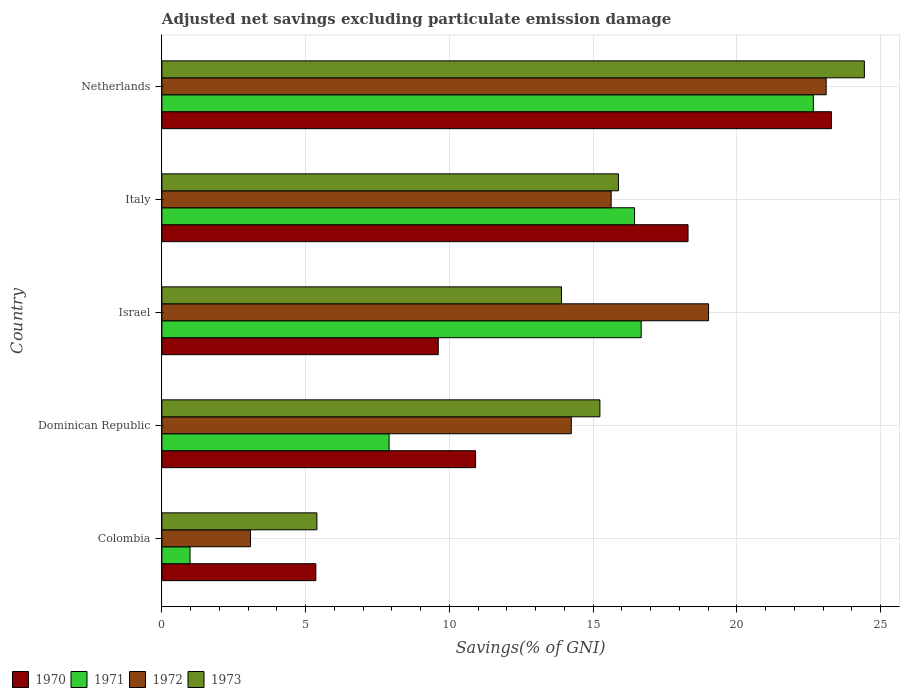How many groups of bars are there?
Your response must be concise. 5. Are the number of bars on each tick of the Y-axis equal?
Give a very brief answer. Yes. How many bars are there on the 1st tick from the top?
Your answer should be compact. 4. How many bars are there on the 5th tick from the bottom?
Make the answer very short. 4. What is the label of the 5th group of bars from the top?
Offer a terse response. Colombia. What is the adjusted net savings in 1970 in Colombia?
Offer a terse response. 5.36. Across all countries, what is the maximum adjusted net savings in 1973?
Offer a terse response. 24.44. Across all countries, what is the minimum adjusted net savings in 1972?
Give a very brief answer. 3.08. What is the total adjusted net savings in 1973 in the graph?
Your answer should be compact. 74.85. What is the difference between the adjusted net savings in 1972 in Dominican Republic and that in Israel?
Ensure brevity in your answer.  -4.78. What is the difference between the adjusted net savings in 1971 in Dominican Republic and the adjusted net savings in 1973 in Netherlands?
Your response must be concise. -16.53. What is the average adjusted net savings in 1973 per country?
Your response must be concise. 14.97. What is the difference between the adjusted net savings in 1971 and adjusted net savings in 1973 in Dominican Republic?
Keep it short and to the point. -7.33. In how many countries, is the adjusted net savings in 1973 greater than 5 %?
Offer a very short reply. 5. What is the ratio of the adjusted net savings in 1973 in Dominican Republic to that in Netherlands?
Your answer should be very brief. 0.62. Is the difference between the adjusted net savings in 1971 in Colombia and Dominican Republic greater than the difference between the adjusted net savings in 1973 in Colombia and Dominican Republic?
Offer a terse response. Yes. What is the difference between the highest and the second highest adjusted net savings in 1973?
Your response must be concise. 8.56. What is the difference between the highest and the lowest adjusted net savings in 1971?
Ensure brevity in your answer.  21.68. Is the sum of the adjusted net savings in 1973 in Colombia and Italy greater than the maximum adjusted net savings in 1972 across all countries?
Your answer should be very brief. No. Is it the case that in every country, the sum of the adjusted net savings in 1972 and adjusted net savings in 1973 is greater than the sum of adjusted net savings in 1971 and adjusted net savings in 1970?
Ensure brevity in your answer.  No. What does the 4th bar from the bottom in Colombia represents?
Your answer should be very brief. 1973. Is it the case that in every country, the sum of the adjusted net savings in 1973 and adjusted net savings in 1971 is greater than the adjusted net savings in 1970?
Your answer should be very brief. Yes. Are all the bars in the graph horizontal?
Ensure brevity in your answer.  Yes. Are the values on the major ticks of X-axis written in scientific E-notation?
Provide a succinct answer. No. Does the graph contain any zero values?
Keep it short and to the point. No. Does the graph contain grids?
Make the answer very short. Yes. Where does the legend appear in the graph?
Provide a short and direct response. Bottom left. What is the title of the graph?
Your response must be concise. Adjusted net savings excluding particulate emission damage. What is the label or title of the X-axis?
Keep it short and to the point. Savings(% of GNI). What is the label or title of the Y-axis?
Provide a succinct answer. Country. What is the Savings(% of GNI) in 1970 in Colombia?
Provide a short and direct response. 5.36. What is the Savings(% of GNI) in 1971 in Colombia?
Offer a terse response. 0.98. What is the Savings(% of GNI) of 1972 in Colombia?
Ensure brevity in your answer.  3.08. What is the Savings(% of GNI) of 1973 in Colombia?
Your answer should be compact. 5.39. What is the Savings(% of GNI) of 1970 in Dominican Republic?
Give a very brief answer. 10.91. What is the Savings(% of GNI) in 1971 in Dominican Republic?
Your response must be concise. 7.9. What is the Savings(% of GNI) in 1972 in Dominican Republic?
Give a very brief answer. 14.24. What is the Savings(% of GNI) of 1973 in Dominican Republic?
Provide a short and direct response. 15.24. What is the Savings(% of GNI) in 1970 in Israel?
Provide a short and direct response. 9.61. What is the Savings(% of GNI) of 1971 in Israel?
Ensure brevity in your answer.  16.67. What is the Savings(% of GNI) of 1972 in Israel?
Provide a succinct answer. 19.02. What is the Savings(% of GNI) of 1973 in Israel?
Your answer should be very brief. 13.9. What is the Savings(% of GNI) in 1970 in Italy?
Give a very brief answer. 18.3. What is the Savings(% of GNI) in 1971 in Italy?
Ensure brevity in your answer.  16.44. What is the Savings(% of GNI) in 1972 in Italy?
Make the answer very short. 15.63. What is the Savings(% of GNI) in 1973 in Italy?
Give a very brief answer. 15.88. What is the Savings(% of GNI) in 1970 in Netherlands?
Offer a terse response. 23.3. What is the Savings(% of GNI) in 1971 in Netherlands?
Give a very brief answer. 22.66. What is the Savings(% of GNI) of 1972 in Netherlands?
Give a very brief answer. 23.11. What is the Savings(% of GNI) of 1973 in Netherlands?
Provide a short and direct response. 24.44. Across all countries, what is the maximum Savings(% of GNI) of 1970?
Provide a succinct answer. 23.3. Across all countries, what is the maximum Savings(% of GNI) of 1971?
Your response must be concise. 22.66. Across all countries, what is the maximum Savings(% of GNI) of 1972?
Make the answer very short. 23.11. Across all countries, what is the maximum Savings(% of GNI) in 1973?
Your answer should be compact. 24.44. Across all countries, what is the minimum Savings(% of GNI) of 1970?
Your response must be concise. 5.36. Across all countries, what is the minimum Savings(% of GNI) of 1971?
Ensure brevity in your answer.  0.98. Across all countries, what is the minimum Savings(% of GNI) in 1972?
Offer a very short reply. 3.08. Across all countries, what is the minimum Savings(% of GNI) of 1973?
Your answer should be very brief. 5.39. What is the total Savings(% of GNI) in 1970 in the graph?
Offer a terse response. 67.48. What is the total Savings(% of GNI) in 1971 in the graph?
Ensure brevity in your answer.  64.66. What is the total Savings(% of GNI) of 1972 in the graph?
Offer a very short reply. 75.08. What is the total Savings(% of GNI) in 1973 in the graph?
Provide a succinct answer. 74.85. What is the difference between the Savings(% of GNI) in 1970 in Colombia and that in Dominican Republic?
Keep it short and to the point. -5.56. What is the difference between the Savings(% of GNI) in 1971 in Colombia and that in Dominican Republic?
Offer a very short reply. -6.92. What is the difference between the Savings(% of GNI) in 1972 in Colombia and that in Dominican Republic?
Your response must be concise. -11.16. What is the difference between the Savings(% of GNI) of 1973 in Colombia and that in Dominican Republic?
Provide a succinct answer. -9.85. What is the difference between the Savings(% of GNI) of 1970 in Colombia and that in Israel?
Make the answer very short. -4.26. What is the difference between the Savings(% of GNI) of 1971 in Colombia and that in Israel?
Offer a very short reply. -15.7. What is the difference between the Savings(% of GNI) in 1972 in Colombia and that in Israel?
Provide a succinct answer. -15.94. What is the difference between the Savings(% of GNI) of 1973 in Colombia and that in Israel?
Your response must be concise. -8.51. What is the difference between the Savings(% of GNI) of 1970 in Colombia and that in Italy?
Provide a short and direct response. -12.95. What is the difference between the Savings(% of GNI) in 1971 in Colombia and that in Italy?
Your response must be concise. -15.46. What is the difference between the Savings(% of GNI) in 1972 in Colombia and that in Italy?
Offer a terse response. -12.55. What is the difference between the Savings(% of GNI) of 1973 in Colombia and that in Italy?
Provide a succinct answer. -10.49. What is the difference between the Savings(% of GNI) in 1970 in Colombia and that in Netherlands?
Provide a short and direct response. -17.94. What is the difference between the Savings(% of GNI) of 1971 in Colombia and that in Netherlands?
Offer a very short reply. -21.68. What is the difference between the Savings(% of GNI) of 1972 in Colombia and that in Netherlands?
Provide a succinct answer. -20.03. What is the difference between the Savings(% of GNI) in 1973 in Colombia and that in Netherlands?
Provide a short and direct response. -19.05. What is the difference between the Savings(% of GNI) in 1970 in Dominican Republic and that in Israel?
Provide a short and direct response. 1.3. What is the difference between the Savings(% of GNI) in 1971 in Dominican Republic and that in Israel?
Your response must be concise. -8.77. What is the difference between the Savings(% of GNI) of 1972 in Dominican Republic and that in Israel?
Make the answer very short. -4.78. What is the difference between the Savings(% of GNI) in 1973 in Dominican Republic and that in Israel?
Your response must be concise. 1.34. What is the difference between the Savings(% of GNI) in 1970 in Dominican Republic and that in Italy?
Keep it short and to the point. -7.39. What is the difference between the Savings(% of GNI) of 1971 in Dominican Republic and that in Italy?
Ensure brevity in your answer.  -8.54. What is the difference between the Savings(% of GNI) of 1972 in Dominican Republic and that in Italy?
Offer a very short reply. -1.39. What is the difference between the Savings(% of GNI) of 1973 in Dominican Republic and that in Italy?
Provide a succinct answer. -0.65. What is the difference between the Savings(% of GNI) of 1970 in Dominican Republic and that in Netherlands?
Your answer should be very brief. -12.38. What is the difference between the Savings(% of GNI) in 1971 in Dominican Republic and that in Netherlands?
Provide a short and direct response. -14.76. What is the difference between the Savings(% of GNI) of 1972 in Dominican Republic and that in Netherlands?
Ensure brevity in your answer.  -8.87. What is the difference between the Savings(% of GNI) of 1973 in Dominican Republic and that in Netherlands?
Offer a terse response. -9.2. What is the difference between the Savings(% of GNI) of 1970 in Israel and that in Italy?
Offer a very short reply. -8.69. What is the difference between the Savings(% of GNI) in 1971 in Israel and that in Italy?
Your answer should be compact. 0.23. What is the difference between the Savings(% of GNI) of 1972 in Israel and that in Italy?
Ensure brevity in your answer.  3.39. What is the difference between the Savings(% of GNI) of 1973 in Israel and that in Italy?
Give a very brief answer. -1.98. What is the difference between the Savings(% of GNI) in 1970 in Israel and that in Netherlands?
Your answer should be compact. -13.68. What is the difference between the Savings(% of GNI) in 1971 in Israel and that in Netherlands?
Your answer should be compact. -5.99. What is the difference between the Savings(% of GNI) of 1972 in Israel and that in Netherlands?
Keep it short and to the point. -4.09. What is the difference between the Savings(% of GNI) in 1973 in Israel and that in Netherlands?
Provide a succinct answer. -10.54. What is the difference between the Savings(% of GNI) of 1970 in Italy and that in Netherlands?
Your answer should be compact. -4.99. What is the difference between the Savings(% of GNI) of 1971 in Italy and that in Netherlands?
Provide a succinct answer. -6.22. What is the difference between the Savings(% of GNI) of 1972 in Italy and that in Netherlands?
Your answer should be compact. -7.48. What is the difference between the Savings(% of GNI) in 1973 in Italy and that in Netherlands?
Give a very brief answer. -8.56. What is the difference between the Savings(% of GNI) in 1970 in Colombia and the Savings(% of GNI) in 1971 in Dominican Republic?
Give a very brief answer. -2.55. What is the difference between the Savings(% of GNI) of 1970 in Colombia and the Savings(% of GNI) of 1972 in Dominican Republic?
Make the answer very short. -8.89. What is the difference between the Savings(% of GNI) of 1970 in Colombia and the Savings(% of GNI) of 1973 in Dominican Republic?
Offer a terse response. -9.88. What is the difference between the Savings(% of GNI) in 1971 in Colombia and the Savings(% of GNI) in 1972 in Dominican Republic?
Keep it short and to the point. -13.26. What is the difference between the Savings(% of GNI) of 1971 in Colombia and the Savings(% of GNI) of 1973 in Dominican Republic?
Offer a terse response. -14.26. What is the difference between the Savings(% of GNI) in 1972 in Colombia and the Savings(% of GNI) in 1973 in Dominican Republic?
Your answer should be very brief. -12.15. What is the difference between the Savings(% of GNI) in 1970 in Colombia and the Savings(% of GNI) in 1971 in Israel?
Provide a short and direct response. -11.32. What is the difference between the Savings(% of GNI) of 1970 in Colombia and the Savings(% of GNI) of 1972 in Israel?
Provide a short and direct response. -13.66. What is the difference between the Savings(% of GNI) in 1970 in Colombia and the Savings(% of GNI) in 1973 in Israel?
Your answer should be very brief. -8.55. What is the difference between the Savings(% of GNI) of 1971 in Colombia and the Savings(% of GNI) of 1972 in Israel?
Your answer should be very brief. -18.04. What is the difference between the Savings(% of GNI) in 1971 in Colombia and the Savings(% of GNI) in 1973 in Israel?
Provide a short and direct response. -12.92. What is the difference between the Savings(% of GNI) of 1972 in Colombia and the Savings(% of GNI) of 1973 in Israel?
Offer a very short reply. -10.82. What is the difference between the Savings(% of GNI) in 1970 in Colombia and the Savings(% of GNI) in 1971 in Italy?
Offer a terse response. -11.09. What is the difference between the Savings(% of GNI) in 1970 in Colombia and the Savings(% of GNI) in 1972 in Italy?
Offer a very short reply. -10.27. What is the difference between the Savings(% of GNI) of 1970 in Colombia and the Savings(% of GNI) of 1973 in Italy?
Make the answer very short. -10.53. What is the difference between the Savings(% of GNI) of 1971 in Colombia and the Savings(% of GNI) of 1972 in Italy?
Your answer should be very brief. -14.65. What is the difference between the Savings(% of GNI) of 1971 in Colombia and the Savings(% of GNI) of 1973 in Italy?
Offer a very short reply. -14.9. What is the difference between the Savings(% of GNI) in 1972 in Colombia and the Savings(% of GNI) in 1973 in Italy?
Your response must be concise. -12.8. What is the difference between the Savings(% of GNI) of 1970 in Colombia and the Savings(% of GNI) of 1971 in Netherlands?
Keep it short and to the point. -17.31. What is the difference between the Savings(% of GNI) of 1970 in Colombia and the Savings(% of GNI) of 1972 in Netherlands?
Ensure brevity in your answer.  -17.75. What is the difference between the Savings(% of GNI) of 1970 in Colombia and the Savings(% of GNI) of 1973 in Netherlands?
Your response must be concise. -19.08. What is the difference between the Savings(% of GNI) of 1971 in Colombia and the Savings(% of GNI) of 1972 in Netherlands?
Give a very brief answer. -22.13. What is the difference between the Savings(% of GNI) in 1971 in Colombia and the Savings(% of GNI) in 1973 in Netherlands?
Ensure brevity in your answer.  -23.46. What is the difference between the Savings(% of GNI) of 1972 in Colombia and the Savings(% of GNI) of 1973 in Netherlands?
Your answer should be very brief. -21.36. What is the difference between the Savings(% of GNI) of 1970 in Dominican Republic and the Savings(% of GNI) of 1971 in Israel?
Your response must be concise. -5.76. What is the difference between the Savings(% of GNI) in 1970 in Dominican Republic and the Savings(% of GNI) in 1972 in Israel?
Keep it short and to the point. -8.11. What is the difference between the Savings(% of GNI) of 1970 in Dominican Republic and the Savings(% of GNI) of 1973 in Israel?
Provide a short and direct response. -2.99. What is the difference between the Savings(% of GNI) of 1971 in Dominican Republic and the Savings(% of GNI) of 1972 in Israel?
Make the answer very short. -11.11. What is the difference between the Savings(% of GNI) in 1971 in Dominican Republic and the Savings(% of GNI) in 1973 in Israel?
Your response must be concise. -6. What is the difference between the Savings(% of GNI) in 1972 in Dominican Republic and the Savings(% of GNI) in 1973 in Israel?
Provide a succinct answer. 0.34. What is the difference between the Savings(% of GNI) in 1970 in Dominican Republic and the Savings(% of GNI) in 1971 in Italy?
Your response must be concise. -5.53. What is the difference between the Savings(% of GNI) of 1970 in Dominican Republic and the Savings(% of GNI) of 1972 in Italy?
Your answer should be very brief. -4.72. What is the difference between the Savings(% of GNI) in 1970 in Dominican Republic and the Savings(% of GNI) in 1973 in Italy?
Your answer should be compact. -4.97. What is the difference between the Savings(% of GNI) in 1971 in Dominican Republic and the Savings(% of GNI) in 1972 in Italy?
Provide a succinct answer. -7.73. What is the difference between the Savings(% of GNI) in 1971 in Dominican Republic and the Savings(% of GNI) in 1973 in Italy?
Offer a very short reply. -7.98. What is the difference between the Savings(% of GNI) of 1972 in Dominican Republic and the Savings(% of GNI) of 1973 in Italy?
Keep it short and to the point. -1.64. What is the difference between the Savings(% of GNI) of 1970 in Dominican Republic and the Savings(% of GNI) of 1971 in Netherlands?
Provide a succinct answer. -11.75. What is the difference between the Savings(% of GNI) of 1970 in Dominican Republic and the Savings(% of GNI) of 1972 in Netherlands?
Your answer should be compact. -12.2. What is the difference between the Savings(% of GNI) of 1970 in Dominican Republic and the Savings(% of GNI) of 1973 in Netherlands?
Give a very brief answer. -13.53. What is the difference between the Savings(% of GNI) in 1971 in Dominican Republic and the Savings(% of GNI) in 1972 in Netherlands?
Offer a very short reply. -15.21. What is the difference between the Savings(% of GNI) of 1971 in Dominican Republic and the Savings(% of GNI) of 1973 in Netherlands?
Keep it short and to the point. -16.53. What is the difference between the Savings(% of GNI) of 1972 in Dominican Republic and the Savings(% of GNI) of 1973 in Netherlands?
Make the answer very short. -10.2. What is the difference between the Savings(% of GNI) of 1970 in Israel and the Savings(% of GNI) of 1971 in Italy?
Provide a short and direct response. -6.83. What is the difference between the Savings(% of GNI) in 1970 in Israel and the Savings(% of GNI) in 1972 in Italy?
Provide a succinct answer. -6.02. What is the difference between the Savings(% of GNI) in 1970 in Israel and the Savings(% of GNI) in 1973 in Italy?
Your answer should be compact. -6.27. What is the difference between the Savings(% of GNI) of 1971 in Israel and the Savings(% of GNI) of 1972 in Italy?
Ensure brevity in your answer.  1.04. What is the difference between the Savings(% of GNI) of 1971 in Israel and the Savings(% of GNI) of 1973 in Italy?
Ensure brevity in your answer.  0.79. What is the difference between the Savings(% of GNI) in 1972 in Israel and the Savings(% of GNI) in 1973 in Italy?
Offer a terse response. 3.14. What is the difference between the Savings(% of GNI) of 1970 in Israel and the Savings(% of GNI) of 1971 in Netherlands?
Give a very brief answer. -13.05. What is the difference between the Savings(% of GNI) of 1970 in Israel and the Savings(% of GNI) of 1972 in Netherlands?
Make the answer very short. -13.49. What is the difference between the Savings(% of GNI) in 1970 in Israel and the Savings(% of GNI) in 1973 in Netherlands?
Your answer should be compact. -14.82. What is the difference between the Savings(% of GNI) in 1971 in Israel and the Savings(% of GNI) in 1972 in Netherlands?
Your response must be concise. -6.44. What is the difference between the Savings(% of GNI) of 1971 in Israel and the Savings(% of GNI) of 1973 in Netherlands?
Make the answer very short. -7.76. What is the difference between the Savings(% of GNI) of 1972 in Israel and the Savings(% of GNI) of 1973 in Netherlands?
Make the answer very short. -5.42. What is the difference between the Savings(% of GNI) in 1970 in Italy and the Savings(% of GNI) in 1971 in Netherlands?
Give a very brief answer. -4.36. What is the difference between the Savings(% of GNI) in 1970 in Italy and the Savings(% of GNI) in 1972 in Netherlands?
Give a very brief answer. -4.81. What is the difference between the Savings(% of GNI) of 1970 in Italy and the Savings(% of GNI) of 1973 in Netherlands?
Make the answer very short. -6.13. What is the difference between the Savings(% of GNI) in 1971 in Italy and the Savings(% of GNI) in 1972 in Netherlands?
Your response must be concise. -6.67. What is the difference between the Savings(% of GNI) in 1971 in Italy and the Savings(% of GNI) in 1973 in Netherlands?
Make the answer very short. -7.99. What is the difference between the Savings(% of GNI) in 1972 in Italy and the Savings(% of GNI) in 1973 in Netherlands?
Keep it short and to the point. -8.81. What is the average Savings(% of GNI) of 1970 per country?
Your response must be concise. 13.5. What is the average Savings(% of GNI) of 1971 per country?
Offer a terse response. 12.93. What is the average Savings(% of GNI) of 1972 per country?
Offer a very short reply. 15.02. What is the average Savings(% of GNI) in 1973 per country?
Your answer should be very brief. 14.97. What is the difference between the Savings(% of GNI) in 1970 and Savings(% of GNI) in 1971 in Colombia?
Your answer should be compact. 4.38. What is the difference between the Savings(% of GNI) of 1970 and Savings(% of GNI) of 1972 in Colombia?
Give a very brief answer. 2.27. What is the difference between the Savings(% of GNI) of 1970 and Savings(% of GNI) of 1973 in Colombia?
Offer a terse response. -0.04. What is the difference between the Savings(% of GNI) of 1971 and Savings(% of GNI) of 1972 in Colombia?
Offer a terse response. -2.1. What is the difference between the Savings(% of GNI) of 1971 and Savings(% of GNI) of 1973 in Colombia?
Your response must be concise. -4.41. What is the difference between the Savings(% of GNI) of 1972 and Savings(% of GNI) of 1973 in Colombia?
Provide a succinct answer. -2.31. What is the difference between the Savings(% of GNI) in 1970 and Savings(% of GNI) in 1971 in Dominican Republic?
Provide a succinct answer. 3.01. What is the difference between the Savings(% of GNI) of 1970 and Savings(% of GNI) of 1972 in Dominican Republic?
Your response must be concise. -3.33. What is the difference between the Savings(% of GNI) in 1970 and Savings(% of GNI) in 1973 in Dominican Republic?
Provide a short and direct response. -4.33. What is the difference between the Savings(% of GNI) of 1971 and Savings(% of GNI) of 1972 in Dominican Republic?
Your response must be concise. -6.34. What is the difference between the Savings(% of GNI) in 1971 and Savings(% of GNI) in 1973 in Dominican Republic?
Provide a succinct answer. -7.33. What is the difference between the Savings(% of GNI) of 1972 and Savings(% of GNI) of 1973 in Dominican Republic?
Offer a very short reply. -1. What is the difference between the Savings(% of GNI) of 1970 and Savings(% of GNI) of 1971 in Israel?
Ensure brevity in your answer.  -7.06. What is the difference between the Savings(% of GNI) of 1970 and Savings(% of GNI) of 1972 in Israel?
Provide a short and direct response. -9.4. What is the difference between the Savings(% of GNI) in 1970 and Savings(% of GNI) in 1973 in Israel?
Offer a terse response. -4.29. What is the difference between the Savings(% of GNI) in 1971 and Savings(% of GNI) in 1972 in Israel?
Ensure brevity in your answer.  -2.34. What is the difference between the Savings(% of GNI) of 1971 and Savings(% of GNI) of 1973 in Israel?
Make the answer very short. 2.77. What is the difference between the Savings(% of GNI) in 1972 and Savings(% of GNI) in 1973 in Israel?
Offer a terse response. 5.12. What is the difference between the Savings(% of GNI) of 1970 and Savings(% of GNI) of 1971 in Italy?
Make the answer very short. 1.86. What is the difference between the Savings(% of GNI) in 1970 and Savings(% of GNI) in 1972 in Italy?
Offer a terse response. 2.67. What is the difference between the Savings(% of GNI) of 1970 and Savings(% of GNI) of 1973 in Italy?
Offer a very short reply. 2.42. What is the difference between the Savings(% of GNI) of 1971 and Savings(% of GNI) of 1972 in Italy?
Provide a short and direct response. 0.81. What is the difference between the Savings(% of GNI) of 1971 and Savings(% of GNI) of 1973 in Italy?
Offer a very short reply. 0.56. What is the difference between the Savings(% of GNI) of 1972 and Savings(% of GNI) of 1973 in Italy?
Give a very brief answer. -0.25. What is the difference between the Savings(% of GNI) in 1970 and Savings(% of GNI) in 1971 in Netherlands?
Make the answer very short. 0.63. What is the difference between the Savings(% of GNI) in 1970 and Savings(% of GNI) in 1972 in Netherlands?
Make the answer very short. 0.19. What is the difference between the Savings(% of GNI) in 1970 and Savings(% of GNI) in 1973 in Netherlands?
Ensure brevity in your answer.  -1.14. What is the difference between the Savings(% of GNI) of 1971 and Savings(% of GNI) of 1972 in Netherlands?
Your answer should be very brief. -0.45. What is the difference between the Savings(% of GNI) in 1971 and Savings(% of GNI) in 1973 in Netherlands?
Make the answer very short. -1.77. What is the difference between the Savings(% of GNI) of 1972 and Savings(% of GNI) of 1973 in Netherlands?
Give a very brief answer. -1.33. What is the ratio of the Savings(% of GNI) in 1970 in Colombia to that in Dominican Republic?
Make the answer very short. 0.49. What is the ratio of the Savings(% of GNI) in 1971 in Colombia to that in Dominican Republic?
Provide a succinct answer. 0.12. What is the ratio of the Savings(% of GNI) in 1972 in Colombia to that in Dominican Republic?
Your answer should be compact. 0.22. What is the ratio of the Savings(% of GNI) in 1973 in Colombia to that in Dominican Republic?
Offer a terse response. 0.35. What is the ratio of the Savings(% of GNI) of 1970 in Colombia to that in Israel?
Provide a succinct answer. 0.56. What is the ratio of the Savings(% of GNI) of 1971 in Colombia to that in Israel?
Provide a succinct answer. 0.06. What is the ratio of the Savings(% of GNI) in 1972 in Colombia to that in Israel?
Make the answer very short. 0.16. What is the ratio of the Savings(% of GNI) in 1973 in Colombia to that in Israel?
Ensure brevity in your answer.  0.39. What is the ratio of the Savings(% of GNI) of 1970 in Colombia to that in Italy?
Your answer should be very brief. 0.29. What is the ratio of the Savings(% of GNI) of 1971 in Colombia to that in Italy?
Your response must be concise. 0.06. What is the ratio of the Savings(% of GNI) of 1972 in Colombia to that in Italy?
Your response must be concise. 0.2. What is the ratio of the Savings(% of GNI) of 1973 in Colombia to that in Italy?
Offer a terse response. 0.34. What is the ratio of the Savings(% of GNI) in 1970 in Colombia to that in Netherlands?
Offer a terse response. 0.23. What is the ratio of the Savings(% of GNI) in 1971 in Colombia to that in Netherlands?
Your response must be concise. 0.04. What is the ratio of the Savings(% of GNI) of 1972 in Colombia to that in Netherlands?
Your answer should be very brief. 0.13. What is the ratio of the Savings(% of GNI) in 1973 in Colombia to that in Netherlands?
Offer a terse response. 0.22. What is the ratio of the Savings(% of GNI) of 1970 in Dominican Republic to that in Israel?
Provide a succinct answer. 1.14. What is the ratio of the Savings(% of GNI) of 1971 in Dominican Republic to that in Israel?
Provide a short and direct response. 0.47. What is the ratio of the Savings(% of GNI) of 1972 in Dominican Republic to that in Israel?
Offer a very short reply. 0.75. What is the ratio of the Savings(% of GNI) of 1973 in Dominican Republic to that in Israel?
Offer a very short reply. 1.1. What is the ratio of the Savings(% of GNI) in 1970 in Dominican Republic to that in Italy?
Give a very brief answer. 0.6. What is the ratio of the Savings(% of GNI) in 1971 in Dominican Republic to that in Italy?
Keep it short and to the point. 0.48. What is the ratio of the Savings(% of GNI) of 1972 in Dominican Republic to that in Italy?
Make the answer very short. 0.91. What is the ratio of the Savings(% of GNI) of 1973 in Dominican Republic to that in Italy?
Your answer should be very brief. 0.96. What is the ratio of the Savings(% of GNI) of 1970 in Dominican Republic to that in Netherlands?
Your response must be concise. 0.47. What is the ratio of the Savings(% of GNI) in 1971 in Dominican Republic to that in Netherlands?
Your answer should be compact. 0.35. What is the ratio of the Savings(% of GNI) in 1972 in Dominican Republic to that in Netherlands?
Keep it short and to the point. 0.62. What is the ratio of the Savings(% of GNI) in 1973 in Dominican Republic to that in Netherlands?
Your answer should be very brief. 0.62. What is the ratio of the Savings(% of GNI) in 1970 in Israel to that in Italy?
Your answer should be very brief. 0.53. What is the ratio of the Savings(% of GNI) of 1972 in Israel to that in Italy?
Keep it short and to the point. 1.22. What is the ratio of the Savings(% of GNI) of 1973 in Israel to that in Italy?
Your response must be concise. 0.88. What is the ratio of the Savings(% of GNI) of 1970 in Israel to that in Netherlands?
Make the answer very short. 0.41. What is the ratio of the Savings(% of GNI) of 1971 in Israel to that in Netherlands?
Provide a succinct answer. 0.74. What is the ratio of the Savings(% of GNI) in 1972 in Israel to that in Netherlands?
Make the answer very short. 0.82. What is the ratio of the Savings(% of GNI) in 1973 in Israel to that in Netherlands?
Your response must be concise. 0.57. What is the ratio of the Savings(% of GNI) of 1970 in Italy to that in Netherlands?
Provide a short and direct response. 0.79. What is the ratio of the Savings(% of GNI) of 1971 in Italy to that in Netherlands?
Your response must be concise. 0.73. What is the ratio of the Savings(% of GNI) of 1972 in Italy to that in Netherlands?
Give a very brief answer. 0.68. What is the ratio of the Savings(% of GNI) in 1973 in Italy to that in Netherlands?
Your response must be concise. 0.65. What is the difference between the highest and the second highest Savings(% of GNI) of 1970?
Ensure brevity in your answer.  4.99. What is the difference between the highest and the second highest Savings(% of GNI) of 1971?
Provide a short and direct response. 5.99. What is the difference between the highest and the second highest Savings(% of GNI) in 1972?
Give a very brief answer. 4.09. What is the difference between the highest and the second highest Savings(% of GNI) of 1973?
Keep it short and to the point. 8.56. What is the difference between the highest and the lowest Savings(% of GNI) in 1970?
Make the answer very short. 17.94. What is the difference between the highest and the lowest Savings(% of GNI) of 1971?
Keep it short and to the point. 21.68. What is the difference between the highest and the lowest Savings(% of GNI) of 1972?
Provide a succinct answer. 20.03. What is the difference between the highest and the lowest Savings(% of GNI) of 1973?
Give a very brief answer. 19.05. 